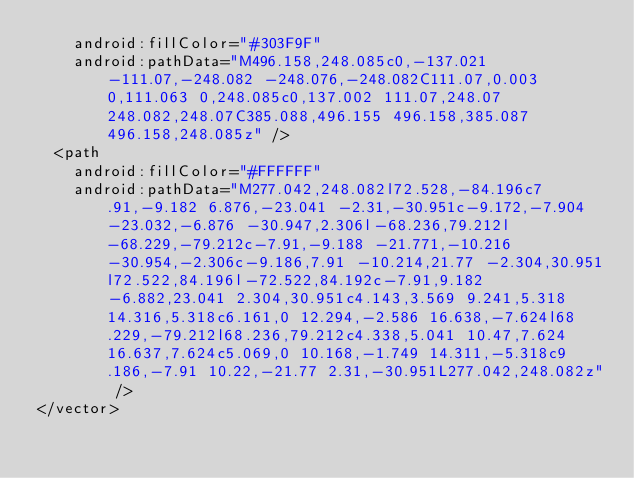<code> <loc_0><loc_0><loc_500><loc_500><_XML_>    android:fillColor="#303F9F"
    android:pathData="M496.158,248.085c0,-137.021 -111.07,-248.082 -248.076,-248.082C111.07,0.003 0,111.063 0,248.085c0,137.002 111.07,248.07 248.082,248.07C385.088,496.155 496.158,385.087 496.158,248.085z" />
  <path
    android:fillColor="#FFFFFF"
    android:pathData="M277.042,248.082l72.528,-84.196c7.91,-9.182 6.876,-23.041 -2.31,-30.951c-9.172,-7.904 -23.032,-6.876 -30.947,2.306l-68.236,79.212l-68.229,-79.212c-7.91,-9.188 -21.771,-10.216 -30.954,-2.306c-9.186,7.91 -10.214,21.77 -2.304,30.951l72.522,84.196l-72.522,84.192c-7.91,9.182 -6.882,23.041 2.304,30.951c4.143,3.569 9.241,5.318 14.316,5.318c6.161,0 12.294,-2.586 16.638,-7.624l68.229,-79.212l68.236,79.212c4.338,5.041 10.47,7.624 16.637,7.624c5.069,0 10.168,-1.749 14.311,-5.318c9.186,-7.91 10.22,-21.77 2.31,-30.951L277.042,248.082z" />
</vector>
</code> 